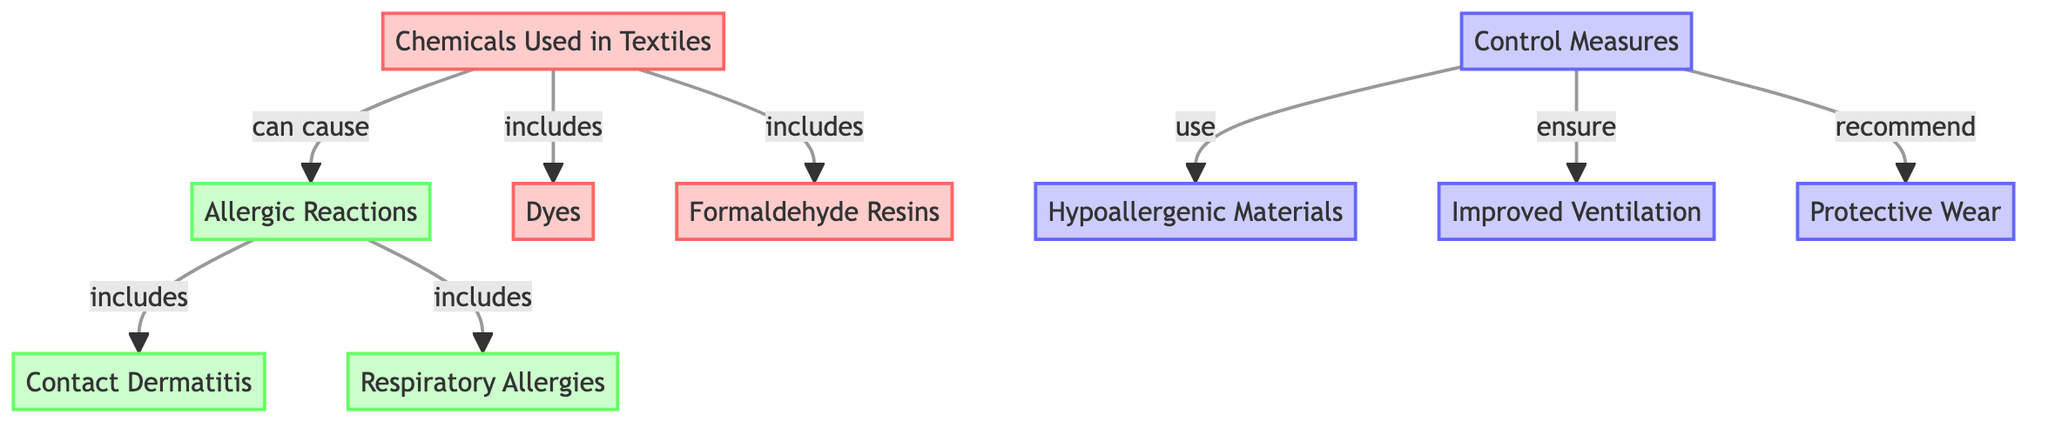What are the two main categories of allergic reactions indicated in the diagram? The diagram shows two specific types of allergic reactions: Contact Dermatitis and Respiratory Allergies, which are included under the broader category of Allergic Reactions.
Answer: Contact Dermatitis, Respiratory Allergies How many types of control measures are presented in the diagram? The diagram lists three control measures: Hypoallergenic Materials, Improved Ventilation, and Protective Wear. By counting these entries, we find there are three control measures in total.
Answer: 3 Which chemical is mentioned in relation to respiratory allergies? The diagram illustrates that the Chemicals Used, which can lead to Allergic Reactions, include the chemical component Dyes. Although respiratory allergies are shown under Allergic Reactions, the specific chemicals causing them are not directly listed under that category. However, Dyes are part of Chemicals Used that can be associated with such allergic responses.
Answer: Dyes What is the relationship between Chemicals Used and Allergic Reactions? The diagram indicates that Chemicals Used can cause Allergic Reactions, establishing a direct connection between the two nodes. Therefore, any chemicals listed could lead to allergic responses.
Answer: can cause What measure is ensured to help control allergic reactions in textiles? According to the diagram, Improved Ventilation is highlighted as a specific control measure that ensures a reduction in allergic reactions related to textiles. This is one of the steps recommended in managing such risks effectively.
Answer: Improved Ventilation How many chemicals are identified as potentially causing allergic reactions in the textile context? The diagram specifies two chemicals, Dyes and Formaldehyde Resins, as being under the Chemicals Used category that can lead to Allergic Reactions. Therefore, counting these, we find there are two distinct chemicals mentioned.
Answer: 2 What type of allergic reaction is explicitly linked with contact dermatitis? In the diagram, contact dermatitis is explicitly labeled as a type of allergic reaction that falls under the broader category of Allergic Reactions. It is clearly represented as one of the specific outcomes of exposure to certain chemicals used in textiles.
Answer: Contact Dermatitis Which control measure directly involves material selection? The diagram indicates that Hypoallergenic Materials is a control measure that involves selecting specific types of materials that are less likely to provoke allergic reactions in individuals exposed to textiles. This measure directly addresses material selection in the context of allergies.
Answer: Hypoallergenic Materials 